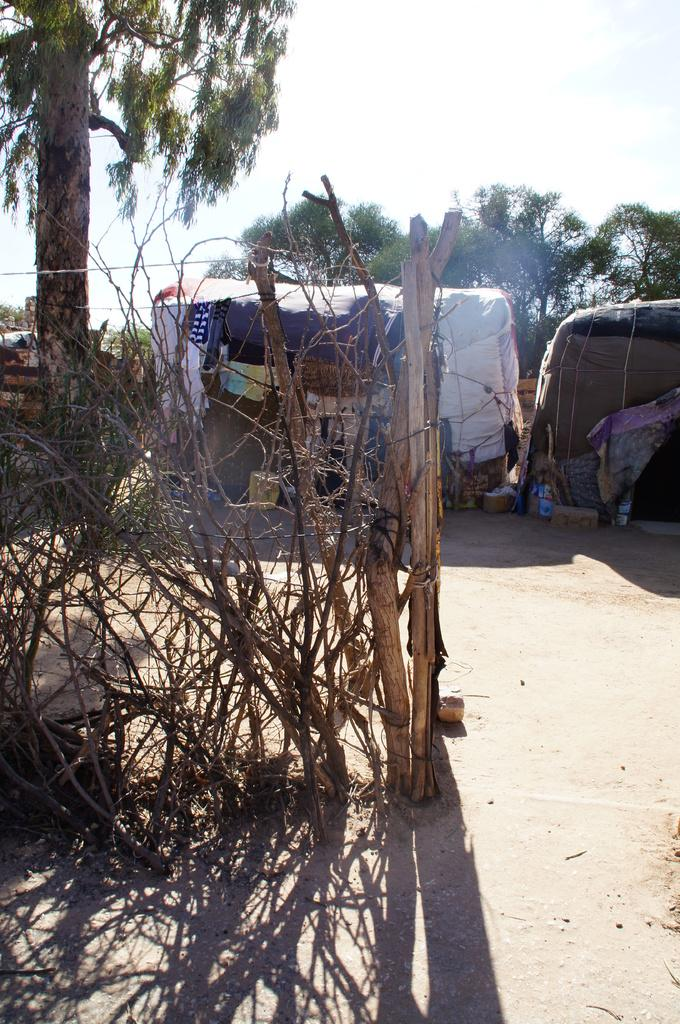What type of structures can be seen in the image? There are huts and shelters in the image. How are the huts and shelters arranged or protected? The huts and shelters are behind a fencing made by stems. What is located on the left side of the image? There is a tree on the left side of the image. Can you describe the vegetation visible behind the huts? There are other trees visible behind the huts. What type of shop can be seen in the image? There is no shop present in the image; it features huts and shelters behind a fencing made by stems. How does the tree on the left side of the image roll in the image? The tree does not roll in the image; it is stationary and standing upright. 